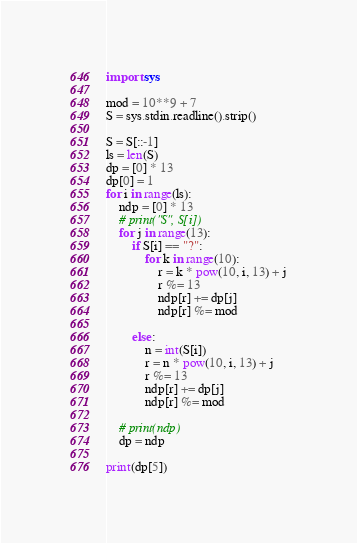<code> <loc_0><loc_0><loc_500><loc_500><_Python_>import sys

mod = 10**9 + 7
S = sys.stdin.readline().strip()

S = S[::-1]
ls = len(S)
dp = [0] * 13
dp[0] = 1
for i in range(ls):
    ndp = [0] * 13
    # print("S", S[i])
    for j in range(13):
        if S[i] == "?":
            for k in range(10):
                r = k * pow(10, i, 13) + j
                r %= 13
                ndp[r] += dp[j]
                ndp[r] %= mod

        else:
            n = int(S[i])
            r = n * pow(10, i, 13) + j
            r %= 13
            ndp[r] += dp[j]
            ndp[r] %= mod

    # print(ndp)
    dp = ndp

print(dp[5])</code> 